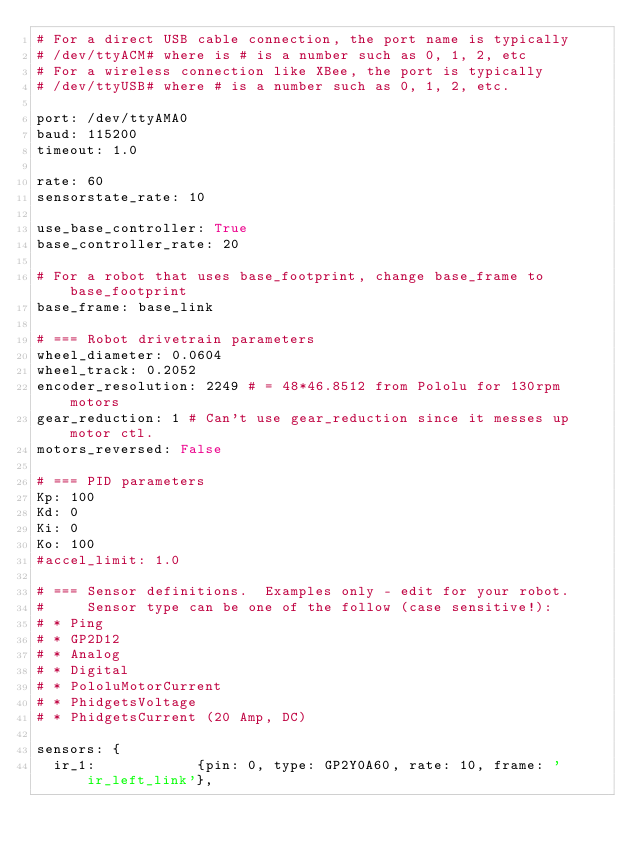<code> <loc_0><loc_0><loc_500><loc_500><_YAML_># For a direct USB cable connection, the port name is typically
# /dev/ttyACM# where is # is a number such as 0, 1, 2, etc
# For a wireless connection like XBee, the port is typically
# /dev/ttyUSB# where # is a number such as 0, 1, 2, etc.

port: /dev/ttyAMA0
baud: 115200
timeout: 1.0

rate: 60
sensorstate_rate: 10

use_base_controller: True
base_controller_rate: 20

# For a robot that uses base_footprint, change base_frame to base_footprint
base_frame: base_link

# === Robot drivetrain parameters
wheel_diameter: 0.0604
wheel_track: 0.2052
encoder_resolution: 2249 # = 48*46.8512 from Pololu for 130rpm motors
gear_reduction: 1 # Can't use gear_reduction since it messes up motor ctl.
motors_reversed: False

# === PID parameters
Kp: 100
Kd: 0
Ki: 0
Ko: 100
#accel_limit: 1.0

# === Sensor definitions.  Examples only - edit for your robot.
#     Sensor type can be one of the follow (case sensitive!):
# * Ping
# * GP2D12
# * Analog
# * Digital
# * PololuMotorCurrent
# * PhidgetsVoltage
# * PhidgetsCurrent (20 Amp, DC)

sensors: {
  ir_1:            {pin: 0, type: GP2Y0A60, rate: 10, frame: 'ir_left_link'},</code> 